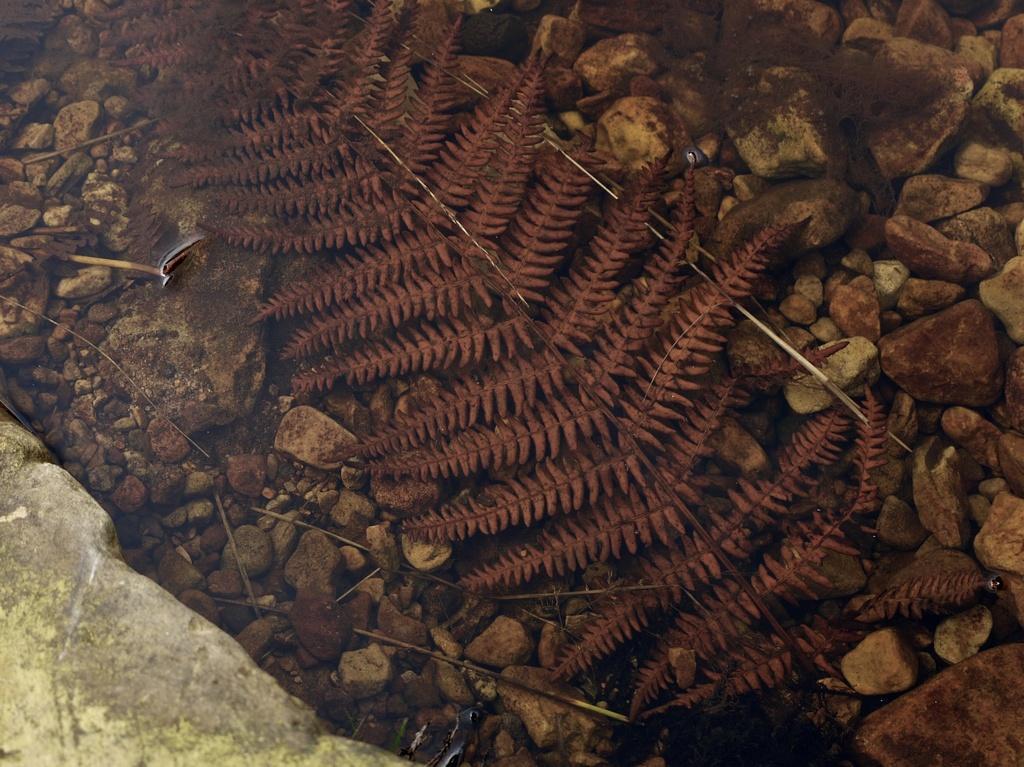In one or two sentences, can you explain what this image depicts? In this picture we can see stones, leaves, sticks on the ground. 